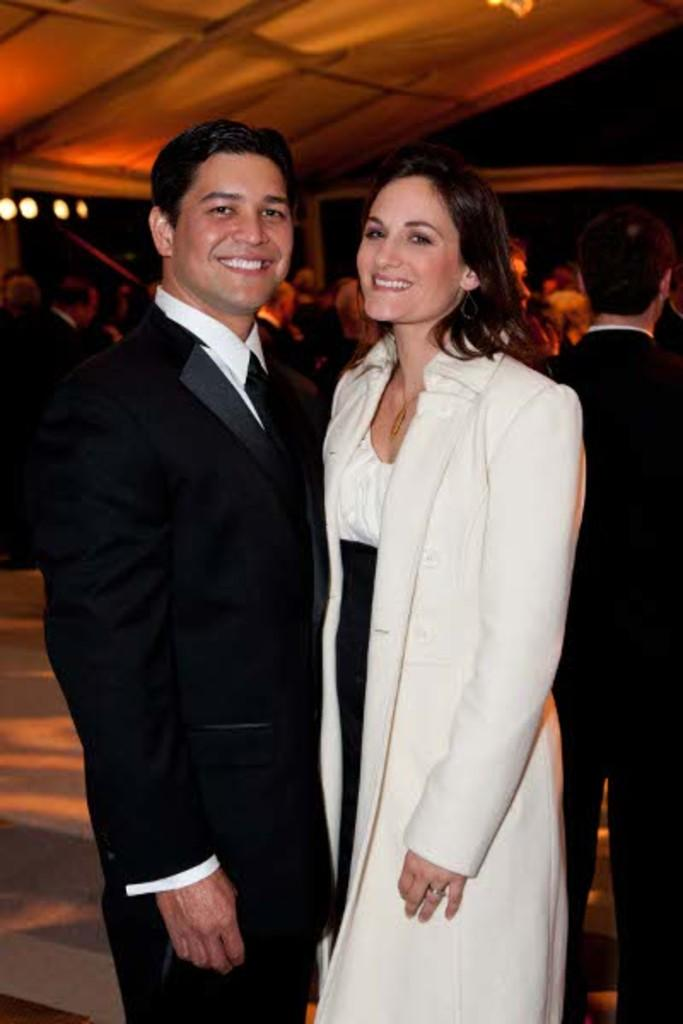What is the man in the image wearing? The man is wearing a black suit. What is the woman in the image wearing? The woman is wearing a white coat. How many people can be seen in the image besides the man and woman? There are many people behind the man and woman. What type of dinner is being served by the scarecrow in the image? There is no scarecrow or dinner present in the image. How much salt is sprinkled on the dish in the image? There is no dish or salt present in the image. 